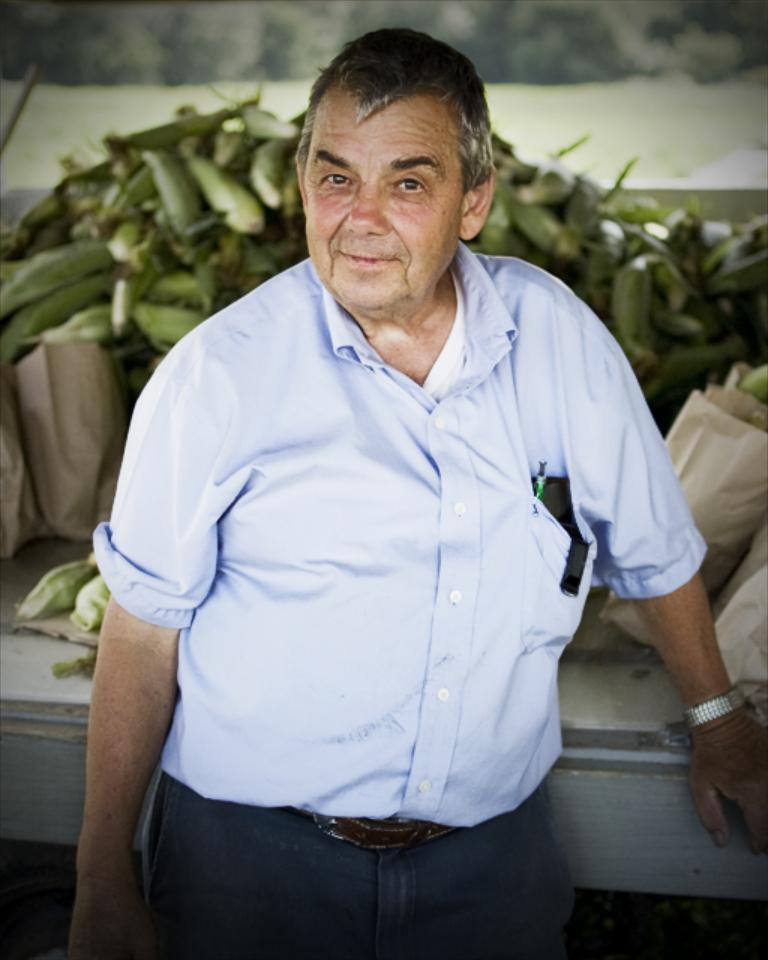How would you summarize this image in a sentence or two? In the picture I can see a man is standing and smiling. The man is wearing a shirt, pant and a belt. In the background I can see bags and some other things on white color surface. 